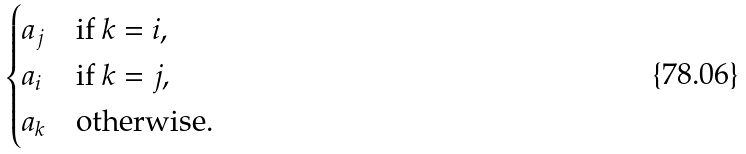<formula> <loc_0><loc_0><loc_500><loc_500>\begin{cases} a _ { j } & \text {if } k = i , \\ a _ { i } & \text {if } k = j , \\ a _ { k } & \text {otherwise.} \end{cases}</formula> 